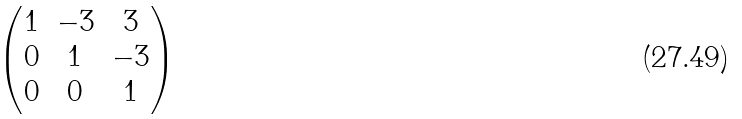<formula> <loc_0><loc_0><loc_500><loc_500>\begin{pmatrix} 1 & - 3 & 3 \\ 0 & 1 & - 3 \\ 0 & 0 & 1 \end{pmatrix}</formula> 